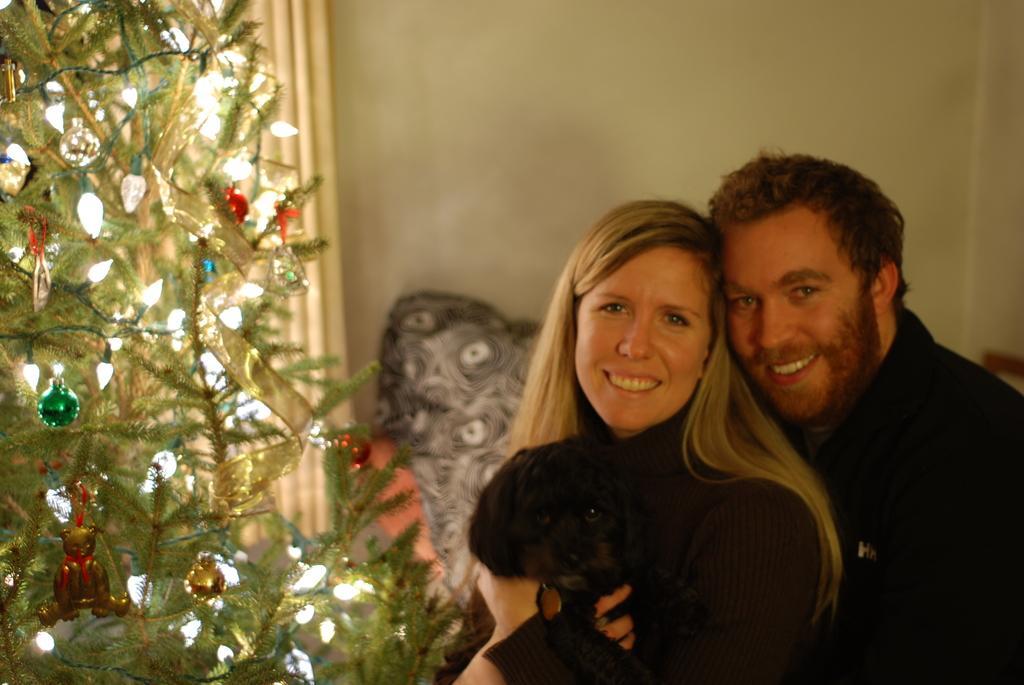Describe this image in one or two sentences. In this image we can see two people, a man and a woman, a woman is holding a dog, there is a tree with some decorative items to the tree and a wall in the background. 